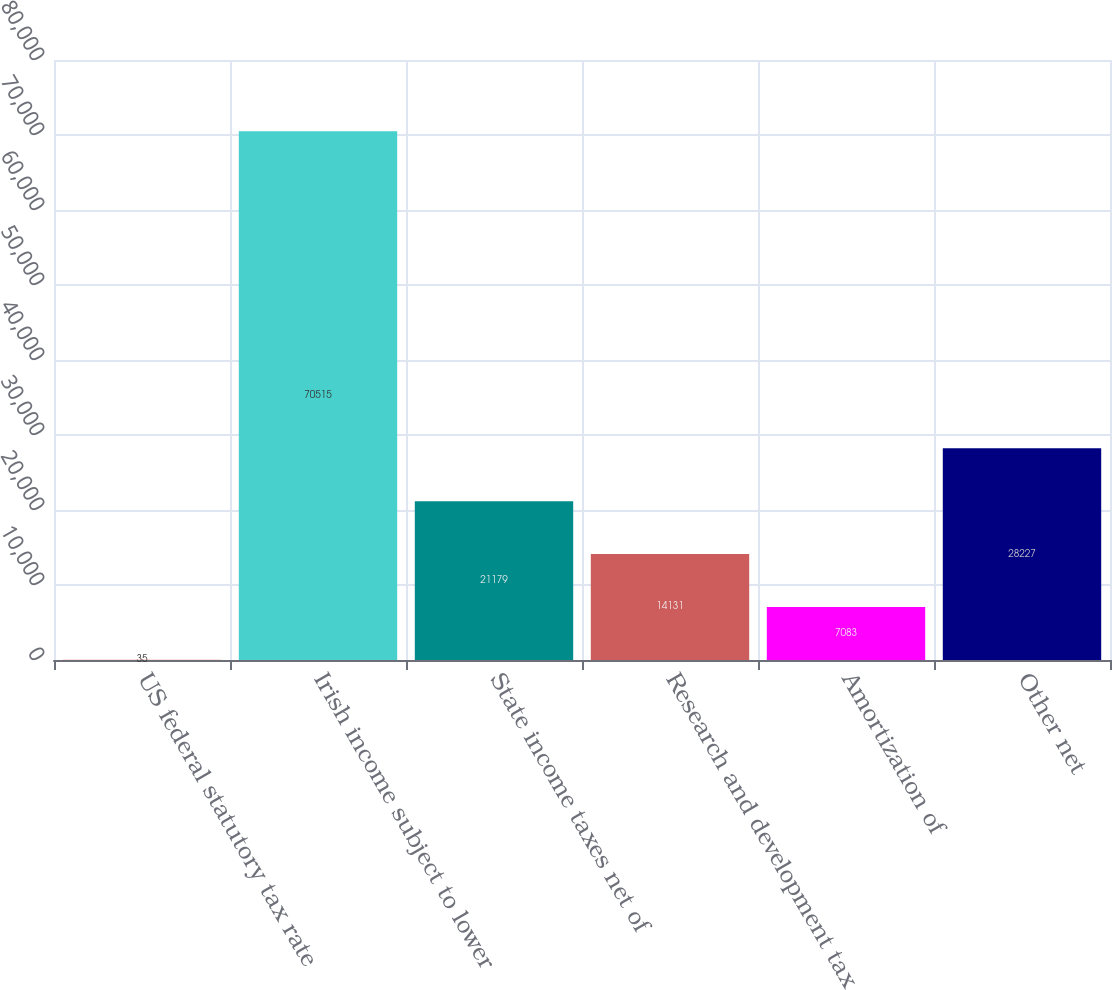<chart> <loc_0><loc_0><loc_500><loc_500><bar_chart><fcel>US federal statutory tax rate<fcel>Irish income subject to lower<fcel>State income taxes net of<fcel>Research and development tax<fcel>Amortization of<fcel>Other net<nl><fcel>35<fcel>70515<fcel>21179<fcel>14131<fcel>7083<fcel>28227<nl></chart> 